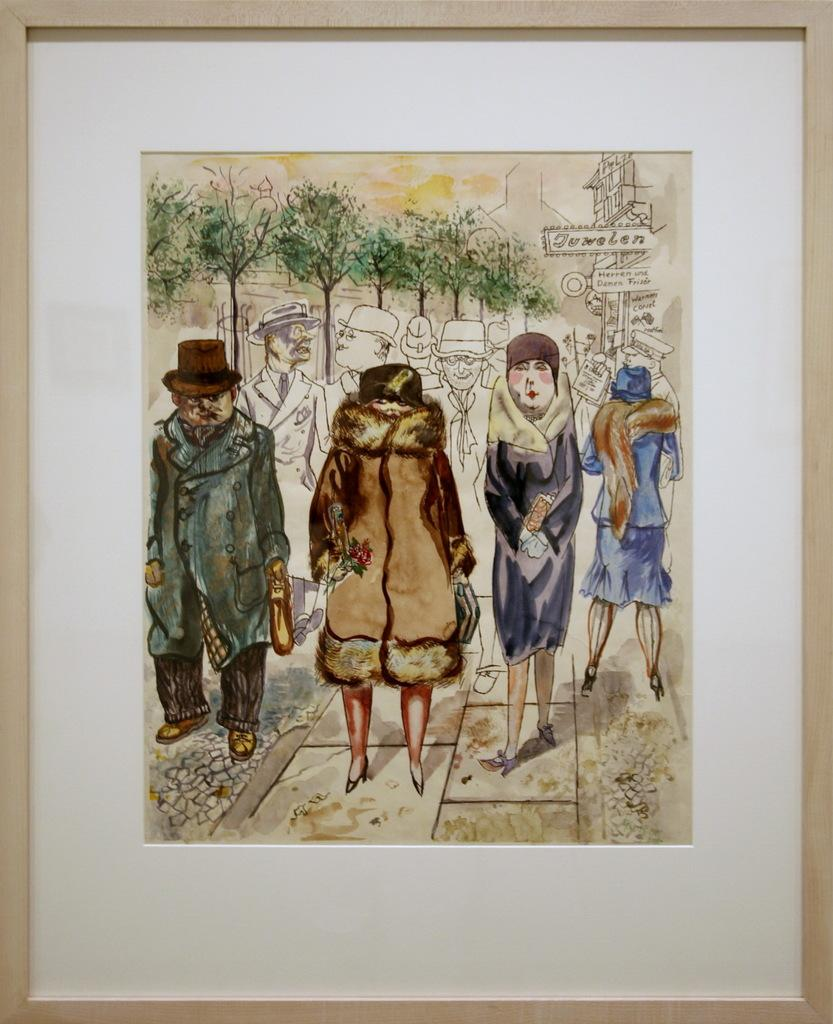What can be seen in the image? There is a poster in the image. What is depicted on the poster? The poster contains images. How many boys are playing in the sand on the poster? There is no mention of boys or sand in the image, as the poster only contains images. 